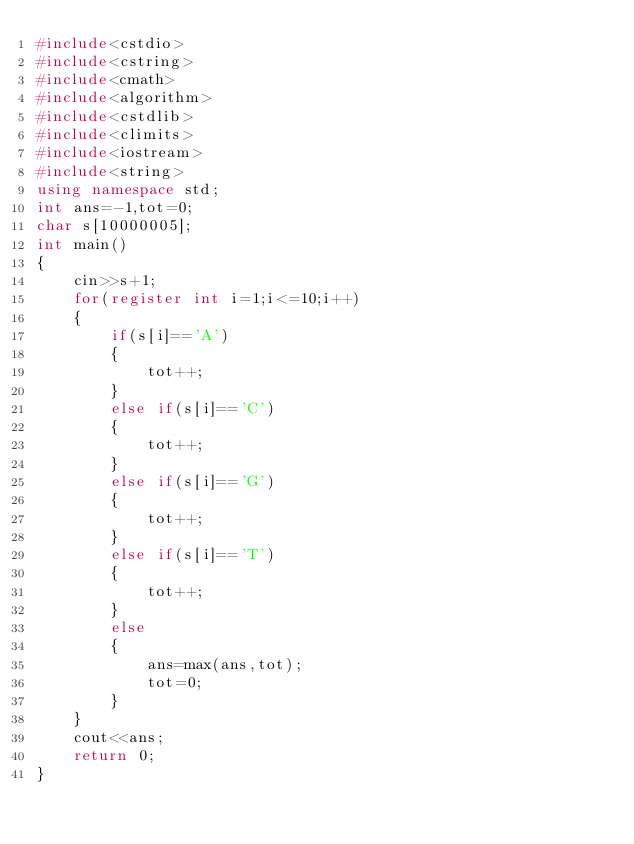<code> <loc_0><loc_0><loc_500><loc_500><_C++_>#include<cstdio>
#include<cstring>
#include<cmath>
#include<algorithm>
#include<cstdlib>
#include<climits>
#include<iostream>
#include<string>
using namespace std;
int ans=-1,tot=0;
char s[10000005];
int main()
{
	cin>>s+1;
	for(register int i=1;i<=10;i++)
	{
		if(s[i]=='A')
		{
			tot++;
		}
		else if(s[i]=='C')
		{
			tot++;
		}
		else if(s[i]=='G')
		{
			tot++;
		}
		else if(s[i]=='T')
		{
			tot++;
		}
		else
		{
			ans=max(ans,tot);
			tot=0;
		}
	}
	cout<<ans;
	return 0;
}</code> 